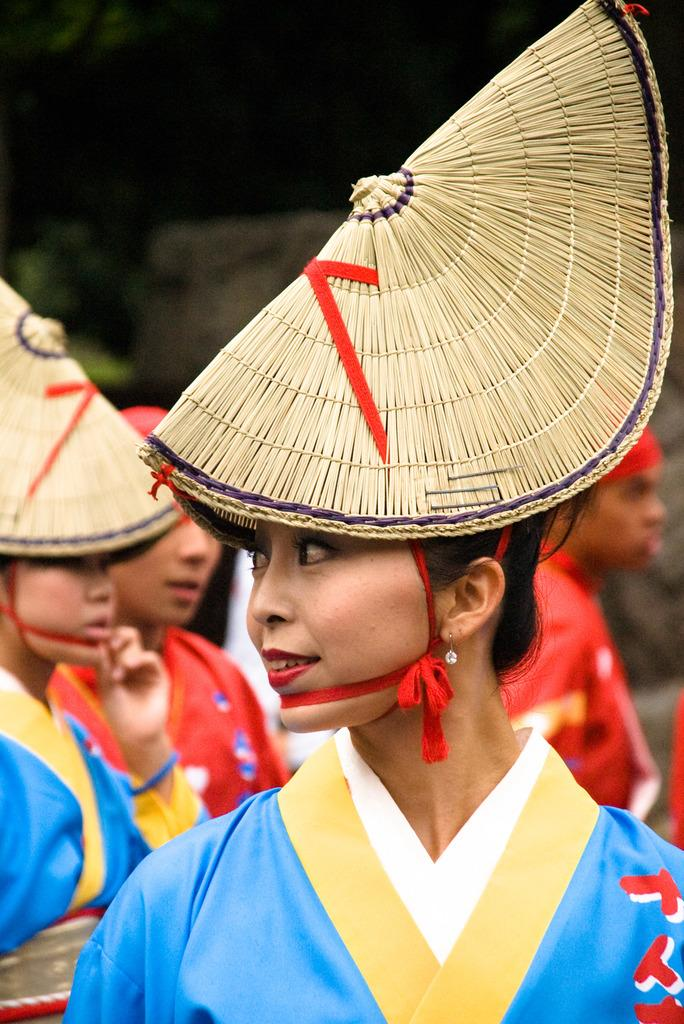Who or what can be seen in the image? There are people in the image. What are the people wearing? The people are wearing costumes. Can you describe the background of the image? The background of the image is blurry. What type of insurance is being discussed by the people in the image? There is no indication in the image that the people are discussing insurance, as they are wearing costumes and the focus is on their attire. 